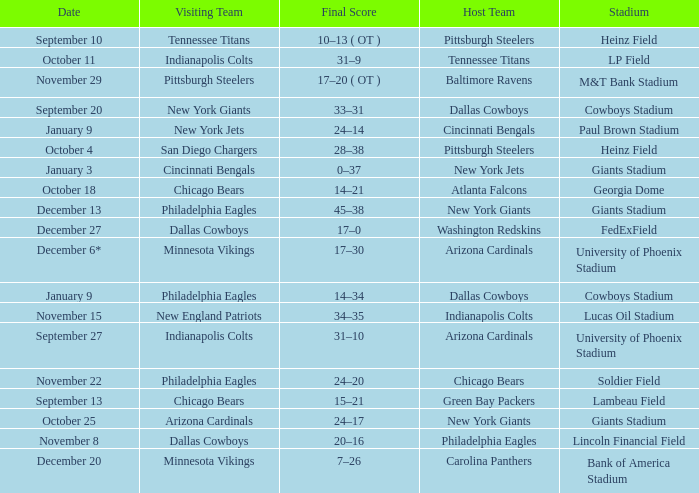Tell me the date for pittsburgh steelers November 29. 